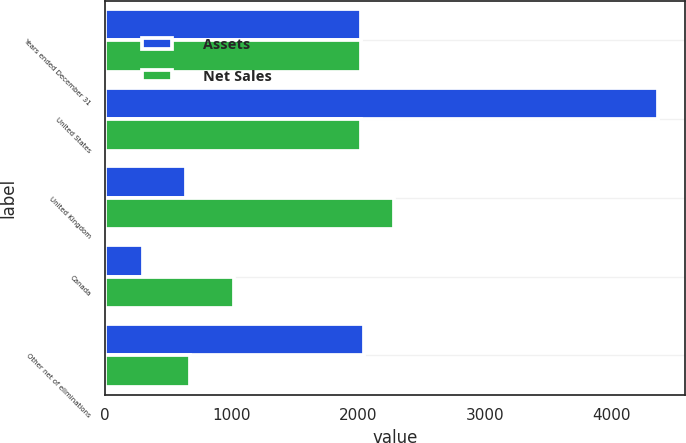<chart> <loc_0><loc_0><loc_500><loc_500><stacked_bar_chart><ecel><fcel>Years ended December 31<fcel>United States<fcel>United Kingdom<fcel>Canada<fcel>Other net of eliminations<nl><fcel>Assets<fcel>2018<fcel>4361<fcel>638<fcel>303<fcel>2041<nl><fcel>Net Sales<fcel>2018<fcel>2018<fcel>2284<fcel>1014<fcel>670<nl></chart> 